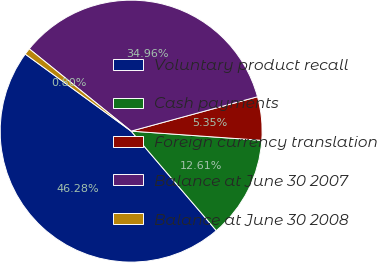Convert chart. <chart><loc_0><loc_0><loc_500><loc_500><pie_chart><fcel>Voluntary product recall<fcel>Cash payments<fcel>Foreign currency translation<fcel>Balance at June 30 2007<fcel>Balance at June 30 2008<nl><fcel>46.28%<fcel>12.61%<fcel>5.35%<fcel>34.96%<fcel>0.8%<nl></chart> 